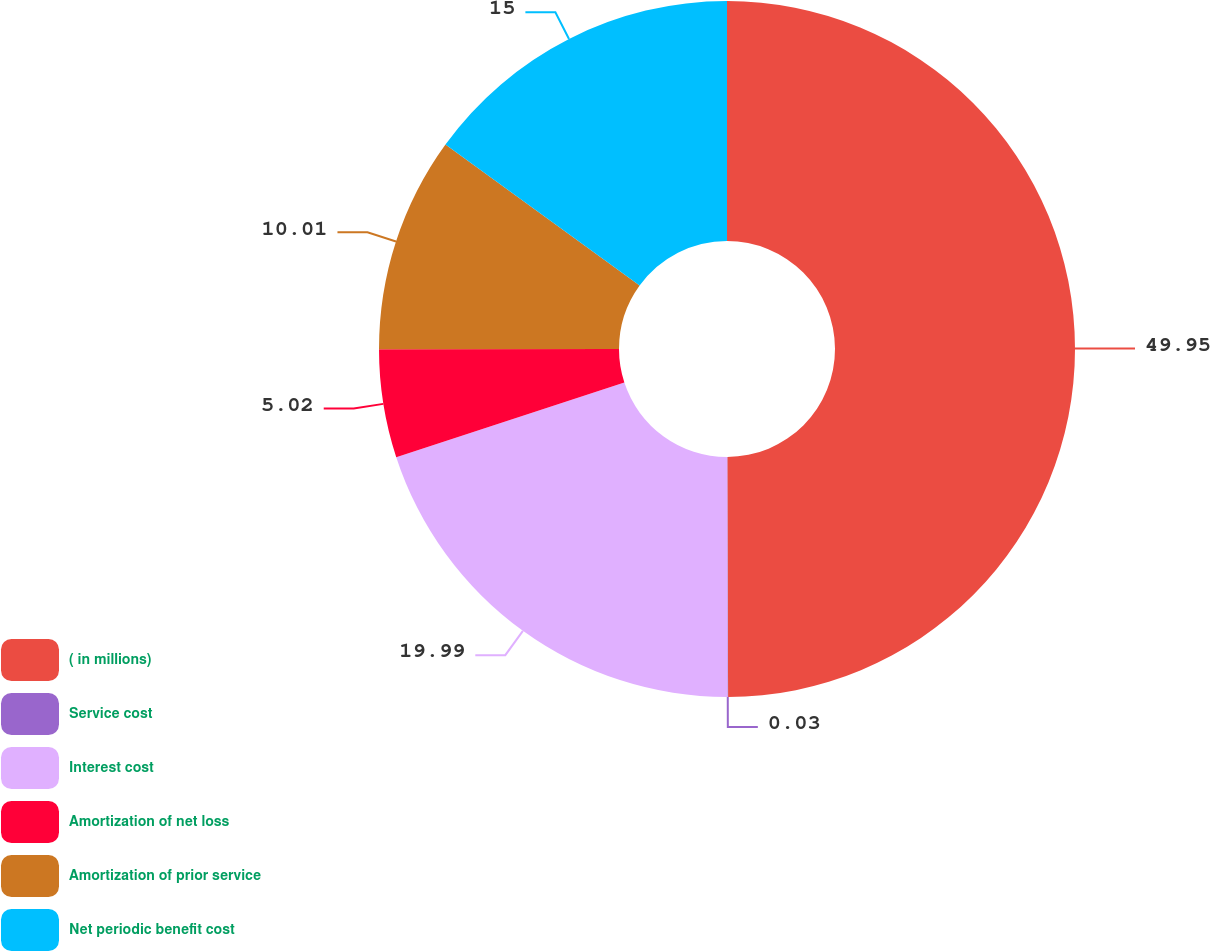Convert chart. <chart><loc_0><loc_0><loc_500><loc_500><pie_chart><fcel>( in millions)<fcel>Service cost<fcel>Interest cost<fcel>Amortization of net loss<fcel>Amortization of prior service<fcel>Net periodic benefit cost<nl><fcel>49.95%<fcel>0.03%<fcel>19.99%<fcel>5.02%<fcel>10.01%<fcel>15.0%<nl></chart> 